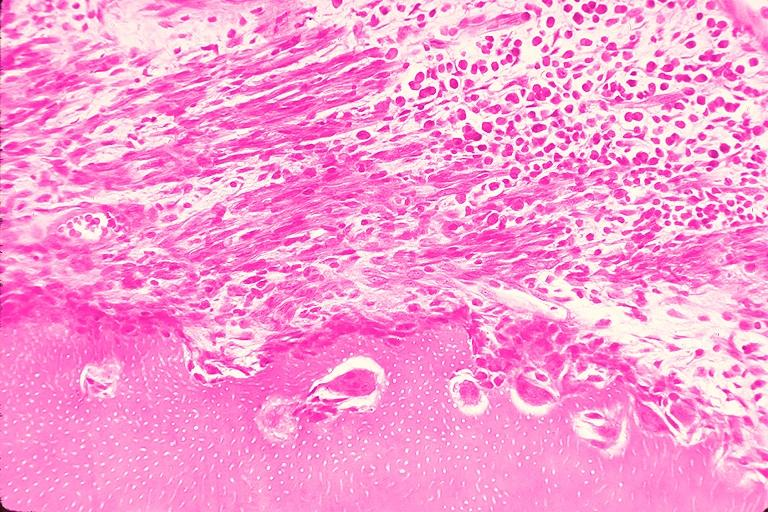what is present?
Answer the question using a single word or phrase. Oral 